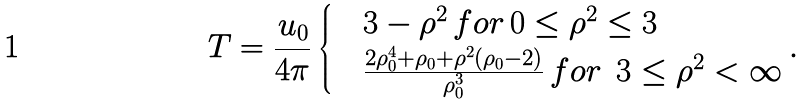Convert formula to latex. <formula><loc_0><loc_0><loc_500><loc_500>T = \frac { u _ { 0 } } { 4 \pi } \begin{cases} & 3 - \rho ^ { 2 } \, f o r \, 0 \leq \rho ^ { 2 } \leq 3 \\ & \frac { 2 \rho _ { 0 } ^ { 4 } + \rho _ { 0 } + \rho ^ { 2 } ( \rho _ { 0 } - 2 ) } { \rho _ { 0 } ^ { 3 } } \, f o r \, \ 3 \leq \rho ^ { 2 } < \infty \end{cases} .</formula> 